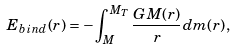<formula> <loc_0><loc_0><loc_500><loc_500>E _ { b i n d } ( r ) = - \int ^ { M _ { T } } _ { M } { \frac { G M ( r ) } { r } d m ( r ) } ,</formula> 